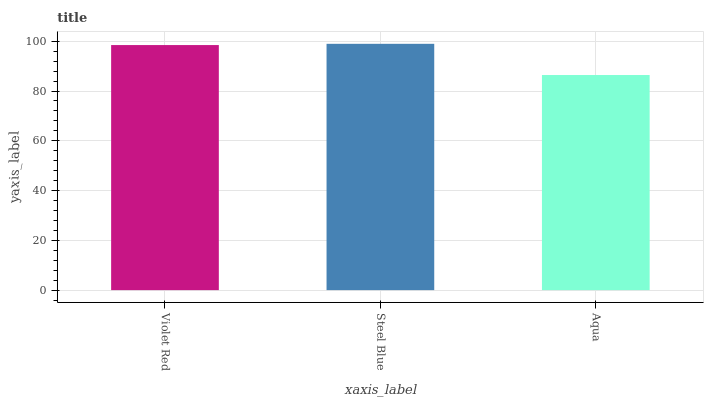Is Aqua the minimum?
Answer yes or no. Yes. Is Steel Blue the maximum?
Answer yes or no. Yes. Is Steel Blue the minimum?
Answer yes or no. No. Is Aqua the maximum?
Answer yes or no. No. Is Steel Blue greater than Aqua?
Answer yes or no. Yes. Is Aqua less than Steel Blue?
Answer yes or no. Yes. Is Aqua greater than Steel Blue?
Answer yes or no. No. Is Steel Blue less than Aqua?
Answer yes or no. No. Is Violet Red the high median?
Answer yes or no. Yes. Is Violet Red the low median?
Answer yes or no. Yes. Is Steel Blue the high median?
Answer yes or no. No. Is Steel Blue the low median?
Answer yes or no. No. 